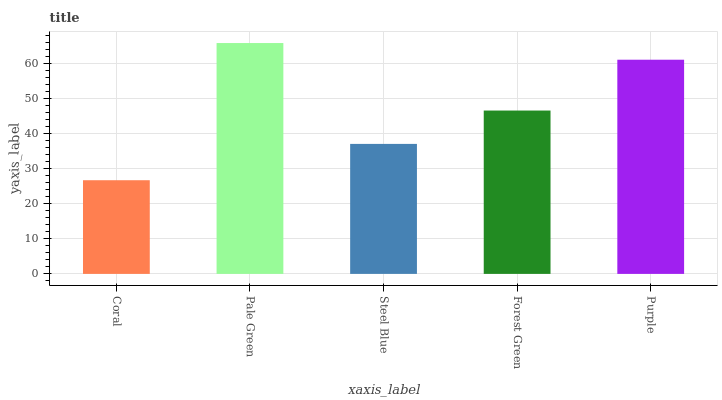Is Steel Blue the minimum?
Answer yes or no. No. Is Steel Blue the maximum?
Answer yes or no. No. Is Pale Green greater than Steel Blue?
Answer yes or no. Yes. Is Steel Blue less than Pale Green?
Answer yes or no. Yes. Is Steel Blue greater than Pale Green?
Answer yes or no. No. Is Pale Green less than Steel Blue?
Answer yes or no. No. Is Forest Green the high median?
Answer yes or no. Yes. Is Forest Green the low median?
Answer yes or no. Yes. Is Pale Green the high median?
Answer yes or no. No. Is Pale Green the low median?
Answer yes or no. No. 